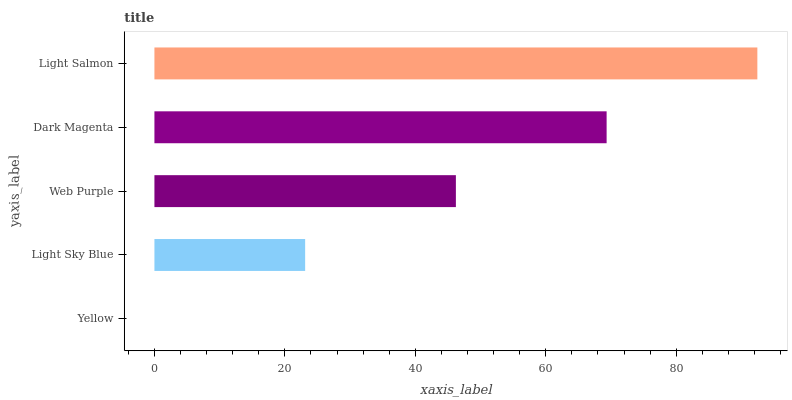Is Yellow the minimum?
Answer yes or no. Yes. Is Light Salmon the maximum?
Answer yes or no. Yes. Is Light Sky Blue the minimum?
Answer yes or no. No. Is Light Sky Blue the maximum?
Answer yes or no. No. Is Light Sky Blue greater than Yellow?
Answer yes or no. Yes. Is Yellow less than Light Sky Blue?
Answer yes or no. Yes. Is Yellow greater than Light Sky Blue?
Answer yes or no. No. Is Light Sky Blue less than Yellow?
Answer yes or no. No. Is Web Purple the high median?
Answer yes or no. Yes. Is Web Purple the low median?
Answer yes or no. Yes. Is Yellow the high median?
Answer yes or no. No. Is Light Sky Blue the low median?
Answer yes or no. No. 